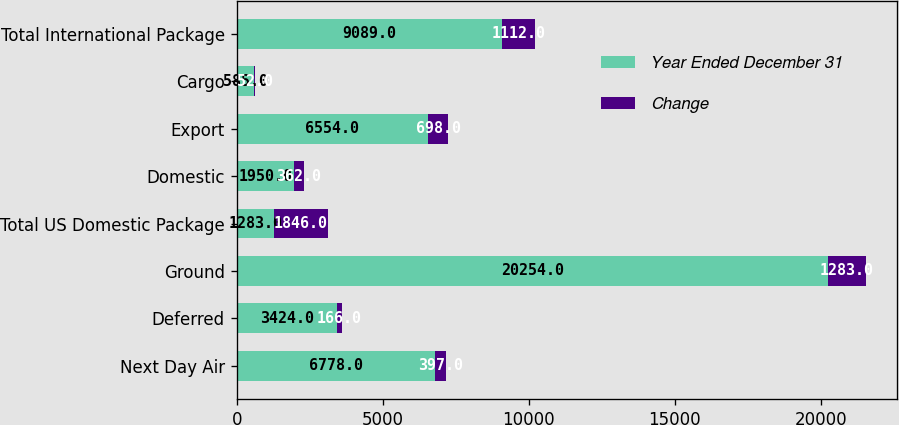Convert chart. <chart><loc_0><loc_0><loc_500><loc_500><stacked_bar_chart><ecel><fcel>Next Day Air<fcel>Deferred<fcel>Ground<fcel>Total US Domestic Package<fcel>Domestic<fcel>Export<fcel>Cargo<fcel>Total International Package<nl><fcel>Year Ended December 31<fcel>6778<fcel>3424<fcel>20254<fcel>1283<fcel>1950<fcel>6554<fcel>585<fcel>9089<nl><fcel>Change<fcel>397<fcel>166<fcel>1283<fcel>1846<fcel>362<fcel>698<fcel>52<fcel>1112<nl></chart> 